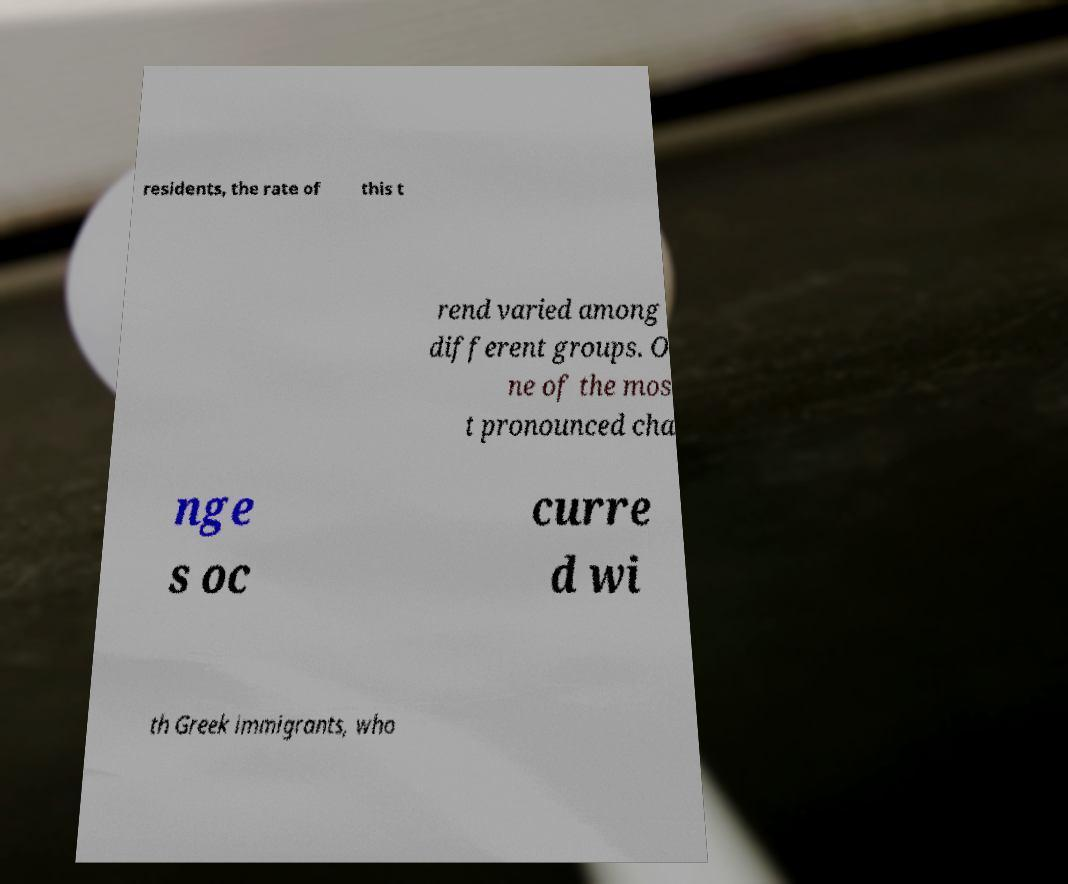There's text embedded in this image that I need extracted. Can you transcribe it verbatim? residents, the rate of this t rend varied among different groups. O ne of the mos t pronounced cha nge s oc curre d wi th Greek immigrants, who 